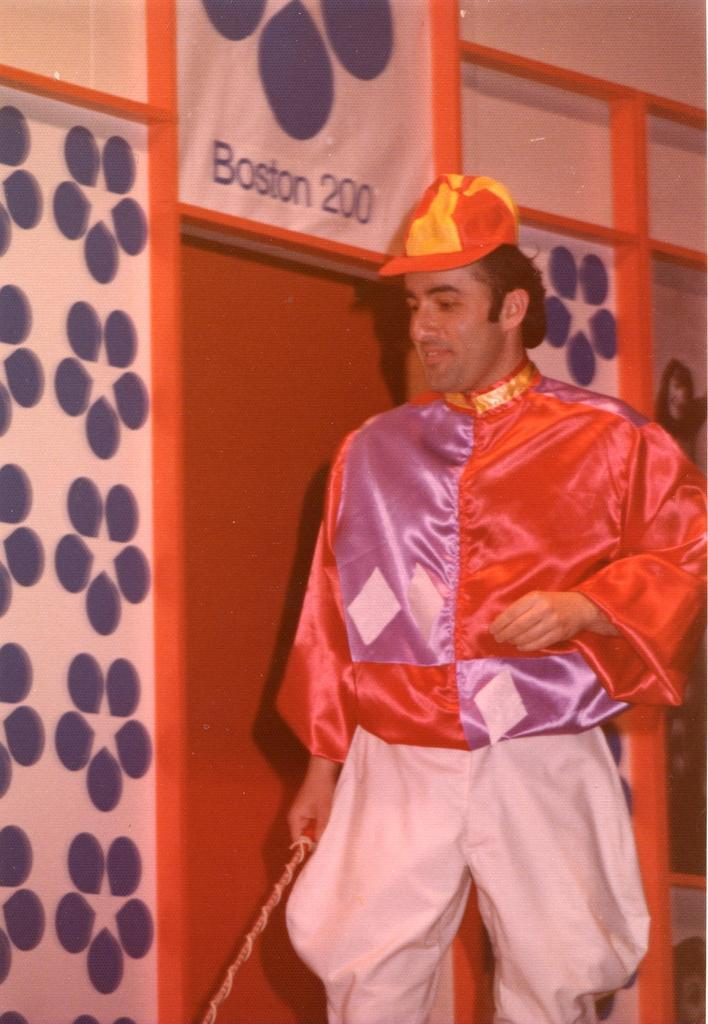Who is present in the image? There is a person in the image. What is the person wearing? The person is wearing a fancy dress. What is the person's posture in the image? The person is standing. What is located near the person in the image? There is a door beside the person. What type of battle is taking place in the image? There is no battle present in the image; it features a person standing near a door while wearing a fancy dress. Where is the person on vacation in the image? The image does not depict a vacation or any travel-related context; it simply shows a person standing near a door. 